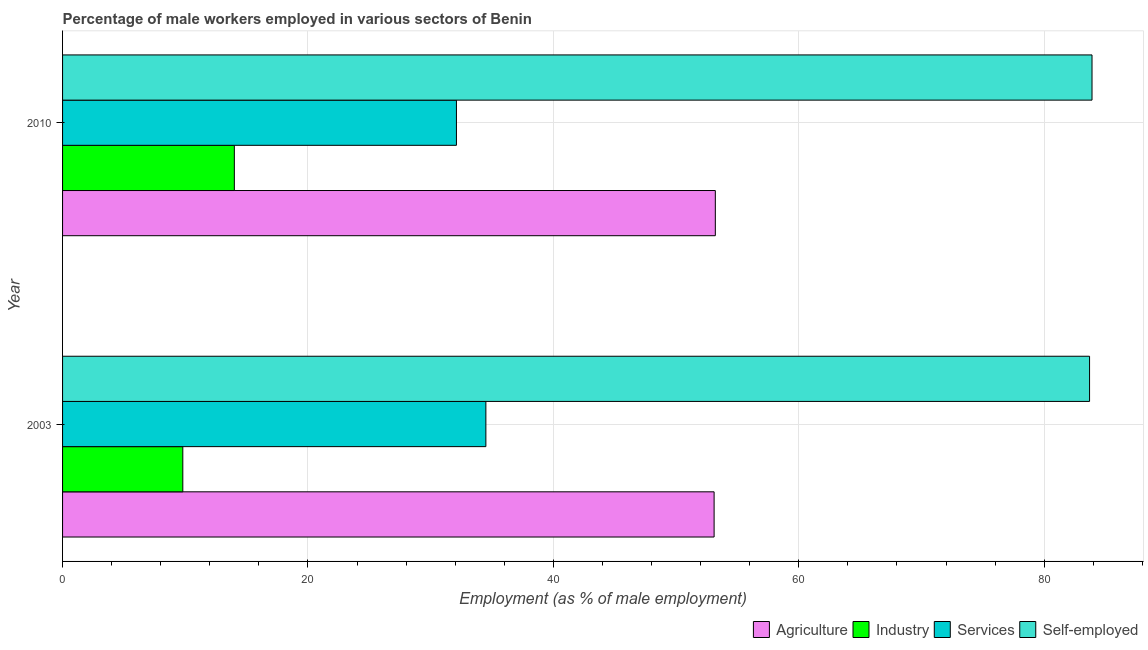How many different coloured bars are there?
Give a very brief answer. 4. Are the number of bars on each tick of the Y-axis equal?
Your answer should be very brief. Yes. What is the label of the 2nd group of bars from the top?
Offer a terse response. 2003. What is the percentage of male workers in agriculture in 2003?
Provide a succinct answer. 53.1. Across all years, what is the maximum percentage of male workers in services?
Offer a very short reply. 34.5. Across all years, what is the minimum percentage of male workers in services?
Your response must be concise. 32.1. In which year was the percentage of self employed male workers maximum?
Provide a succinct answer. 2010. What is the total percentage of male workers in agriculture in the graph?
Give a very brief answer. 106.3. What is the difference between the percentage of male workers in services in 2003 and that in 2010?
Your response must be concise. 2.4. What is the difference between the percentage of self employed male workers in 2010 and the percentage of male workers in services in 2003?
Keep it short and to the point. 49.4. What is the average percentage of male workers in agriculture per year?
Provide a succinct answer. 53.15. In the year 2010, what is the difference between the percentage of self employed male workers and percentage of male workers in services?
Keep it short and to the point. 51.8. In how many years, is the percentage of male workers in services greater than 36 %?
Your response must be concise. 0. What is the ratio of the percentage of male workers in agriculture in 2003 to that in 2010?
Ensure brevity in your answer.  1. In how many years, is the percentage of self employed male workers greater than the average percentage of self employed male workers taken over all years?
Make the answer very short. 1. What does the 2nd bar from the top in 2010 represents?
Your answer should be compact. Services. What does the 2nd bar from the bottom in 2003 represents?
Your answer should be compact. Industry. How many bars are there?
Keep it short and to the point. 8. How many years are there in the graph?
Give a very brief answer. 2. What is the difference between two consecutive major ticks on the X-axis?
Your response must be concise. 20. Are the values on the major ticks of X-axis written in scientific E-notation?
Provide a short and direct response. No. Does the graph contain any zero values?
Make the answer very short. No. Does the graph contain grids?
Your answer should be very brief. Yes. Where does the legend appear in the graph?
Keep it short and to the point. Bottom right. How are the legend labels stacked?
Offer a terse response. Horizontal. What is the title of the graph?
Your response must be concise. Percentage of male workers employed in various sectors of Benin. Does "Macroeconomic management" appear as one of the legend labels in the graph?
Ensure brevity in your answer.  No. What is the label or title of the X-axis?
Your response must be concise. Employment (as % of male employment). What is the Employment (as % of male employment) in Agriculture in 2003?
Provide a succinct answer. 53.1. What is the Employment (as % of male employment) in Industry in 2003?
Ensure brevity in your answer.  9.8. What is the Employment (as % of male employment) of Services in 2003?
Offer a terse response. 34.5. What is the Employment (as % of male employment) in Self-employed in 2003?
Provide a succinct answer. 83.7. What is the Employment (as % of male employment) in Agriculture in 2010?
Make the answer very short. 53.2. What is the Employment (as % of male employment) of Industry in 2010?
Give a very brief answer. 14. What is the Employment (as % of male employment) of Services in 2010?
Offer a terse response. 32.1. What is the Employment (as % of male employment) of Self-employed in 2010?
Your answer should be very brief. 83.9. Across all years, what is the maximum Employment (as % of male employment) in Agriculture?
Your response must be concise. 53.2. Across all years, what is the maximum Employment (as % of male employment) in Services?
Provide a short and direct response. 34.5. Across all years, what is the maximum Employment (as % of male employment) of Self-employed?
Give a very brief answer. 83.9. Across all years, what is the minimum Employment (as % of male employment) of Agriculture?
Make the answer very short. 53.1. Across all years, what is the minimum Employment (as % of male employment) in Industry?
Your answer should be very brief. 9.8. Across all years, what is the minimum Employment (as % of male employment) of Services?
Provide a succinct answer. 32.1. Across all years, what is the minimum Employment (as % of male employment) in Self-employed?
Your answer should be very brief. 83.7. What is the total Employment (as % of male employment) of Agriculture in the graph?
Your answer should be very brief. 106.3. What is the total Employment (as % of male employment) of Industry in the graph?
Give a very brief answer. 23.8. What is the total Employment (as % of male employment) in Services in the graph?
Offer a terse response. 66.6. What is the total Employment (as % of male employment) in Self-employed in the graph?
Your answer should be very brief. 167.6. What is the difference between the Employment (as % of male employment) of Agriculture in 2003 and that in 2010?
Offer a very short reply. -0.1. What is the difference between the Employment (as % of male employment) of Industry in 2003 and that in 2010?
Your answer should be very brief. -4.2. What is the difference between the Employment (as % of male employment) of Self-employed in 2003 and that in 2010?
Make the answer very short. -0.2. What is the difference between the Employment (as % of male employment) in Agriculture in 2003 and the Employment (as % of male employment) in Industry in 2010?
Ensure brevity in your answer.  39.1. What is the difference between the Employment (as % of male employment) in Agriculture in 2003 and the Employment (as % of male employment) in Services in 2010?
Your answer should be compact. 21. What is the difference between the Employment (as % of male employment) of Agriculture in 2003 and the Employment (as % of male employment) of Self-employed in 2010?
Provide a short and direct response. -30.8. What is the difference between the Employment (as % of male employment) in Industry in 2003 and the Employment (as % of male employment) in Services in 2010?
Ensure brevity in your answer.  -22.3. What is the difference between the Employment (as % of male employment) in Industry in 2003 and the Employment (as % of male employment) in Self-employed in 2010?
Your response must be concise. -74.1. What is the difference between the Employment (as % of male employment) of Services in 2003 and the Employment (as % of male employment) of Self-employed in 2010?
Your response must be concise. -49.4. What is the average Employment (as % of male employment) of Agriculture per year?
Make the answer very short. 53.15. What is the average Employment (as % of male employment) of Services per year?
Your answer should be very brief. 33.3. What is the average Employment (as % of male employment) in Self-employed per year?
Your answer should be compact. 83.8. In the year 2003, what is the difference between the Employment (as % of male employment) of Agriculture and Employment (as % of male employment) of Industry?
Provide a succinct answer. 43.3. In the year 2003, what is the difference between the Employment (as % of male employment) of Agriculture and Employment (as % of male employment) of Services?
Provide a short and direct response. 18.6. In the year 2003, what is the difference between the Employment (as % of male employment) of Agriculture and Employment (as % of male employment) of Self-employed?
Provide a short and direct response. -30.6. In the year 2003, what is the difference between the Employment (as % of male employment) of Industry and Employment (as % of male employment) of Services?
Ensure brevity in your answer.  -24.7. In the year 2003, what is the difference between the Employment (as % of male employment) in Industry and Employment (as % of male employment) in Self-employed?
Offer a very short reply. -73.9. In the year 2003, what is the difference between the Employment (as % of male employment) in Services and Employment (as % of male employment) in Self-employed?
Keep it short and to the point. -49.2. In the year 2010, what is the difference between the Employment (as % of male employment) of Agriculture and Employment (as % of male employment) of Industry?
Provide a short and direct response. 39.2. In the year 2010, what is the difference between the Employment (as % of male employment) in Agriculture and Employment (as % of male employment) in Services?
Ensure brevity in your answer.  21.1. In the year 2010, what is the difference between the Employment (as % of male employment) of Agriculture and Employment (as % of male employment) of Self-employed?
Offer a terse response. -30.7. In the year 2010, what is the difference between the Employment (as % of male employment) of Industry and Employment (as % of male employment) of Services?
Ensure brevity in your answer.  -18.1. In the year 2010, what is the difference between the Employment (as % of male employment) of Industry and Employment (as % of male employment) of Self-employed?
Provide a short and direct response. -69.9. In the year 2010, what is the difference between the Employment (as % of male employment) of Services and Employment (as % of male employment) of Self-employed?
Your response must be concise. -51.8. What is the ratio of the Employment (as % of male employment) in Agriculture in 2003 to that in 2010?
Offer a very short reply. 1. What is the ratio of the Employment (as % of male employment) of Services in 2003 to that in 2010?
Offer a very short reply. 1.07. What is the ratio of the Employment (as % of male employment) in Self-employed in 2003 to that in 2010?
Offer a very short reply. 1. What is the difference between the highest and the second highest Employment (as % of male employment) of Agriculture?
Your response must be concise. 0.1. What is the difference between the highest and the lowest Employment (as % of male employment) of Industry?
Offer a terse response. 4.2. What is the difference between the highest and the lowest Employment (as % of male employment) of Services?
Your response must be concise. 2.4. What is the difference between the highest and the lowest Employment (as % of male employment) of Self-employed?
Keep it short and to the point. 0.2. 